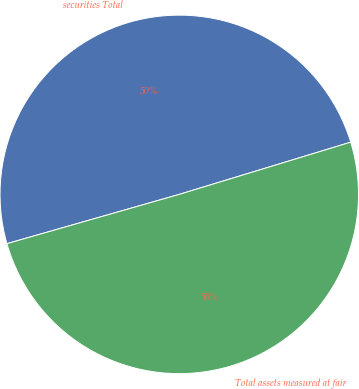Convert chart to OTSL. <chart><loc_0><loc_0><loc_500><loc_500><pie_chart><fcel>securities Total<fcel>Total assets measured at fair<nl><fcel>49.73%<fcel>50.27%<nl></chart> 